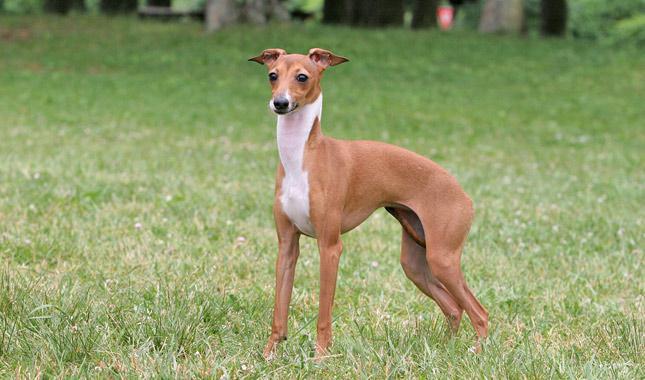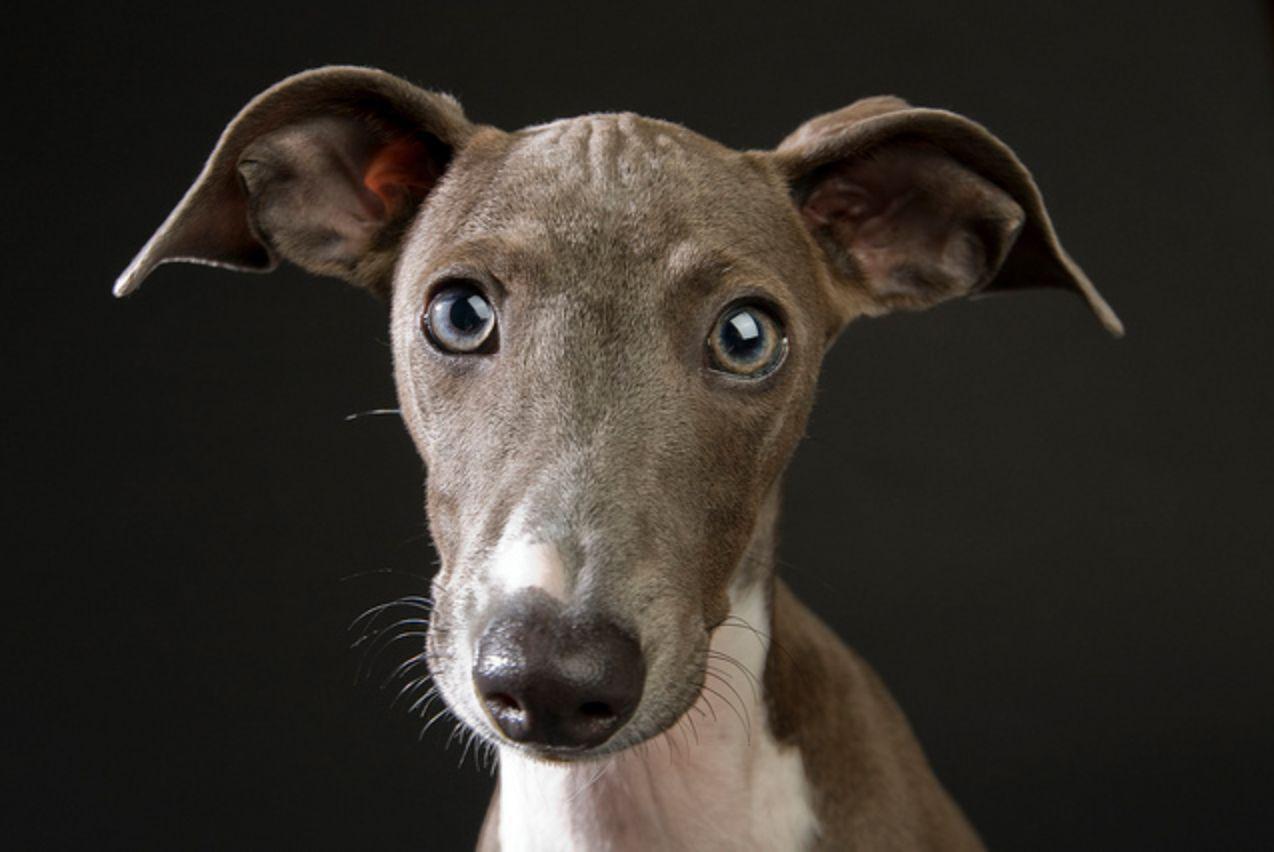The first image is the image on the left, the second image is the image on the right. Analyze the images presented: Is the assertion "Exactly one dog wears a bright red collar." valid? Answer yes or no. No. The first image is the image on the left, the second image is the image on the right. For the images shown, is this caption "A grayish hound with white chest marking is wearing a bright red collar." true? Answer yes or no. No. 